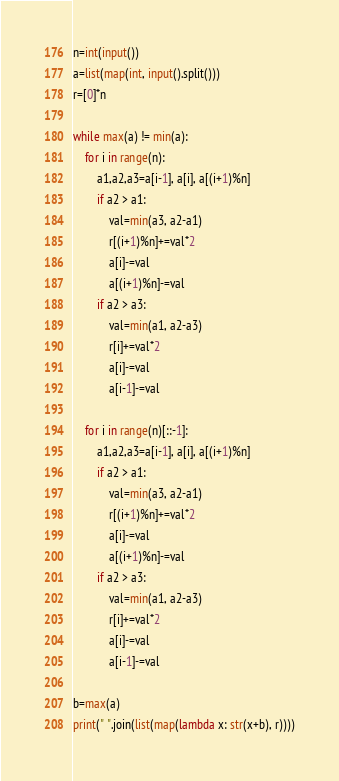Convert code to text. <code><loc_0><loc_0><loc_500><loc_500><_Python_>n=int(input())
a=list(map(int, input().split()))
r=[0]*n

while max(a) != min(a):
    for i in range(n):
        a1,a2,a3=a[i-1], a[i], a[(i+1)%n]
        if a2 > a1:
            val=min(a3, a2-a1)
            r[(i+1)%n]+=val*2
            a[i]-=val
            a[(i+1)%n]-=val
        if a2 > a3:
            val=min(a1, a2-a3)
            r[i]+=val*2
            a[i]-=val
            a[i-1]-=val

    for i in range(n)[::-1]:
        a1,a2,a3=a[i-1], a[i], a[(i+1)%n]
        if a2 > a1:
            val=min(a3, a2-a1)
            r[(i+1)%n]+=val*2
            a[i]-=val
            a[(i+1)%n]-=val
        if a2 > a3:
            val=min(a1, a2-a3)
            r[i]+=val*2
            a[i]-=val
            a[i-1]-=val

b=max(a)
print(" ".join(list(map(lambda x: str(x+b), r))))</code> 